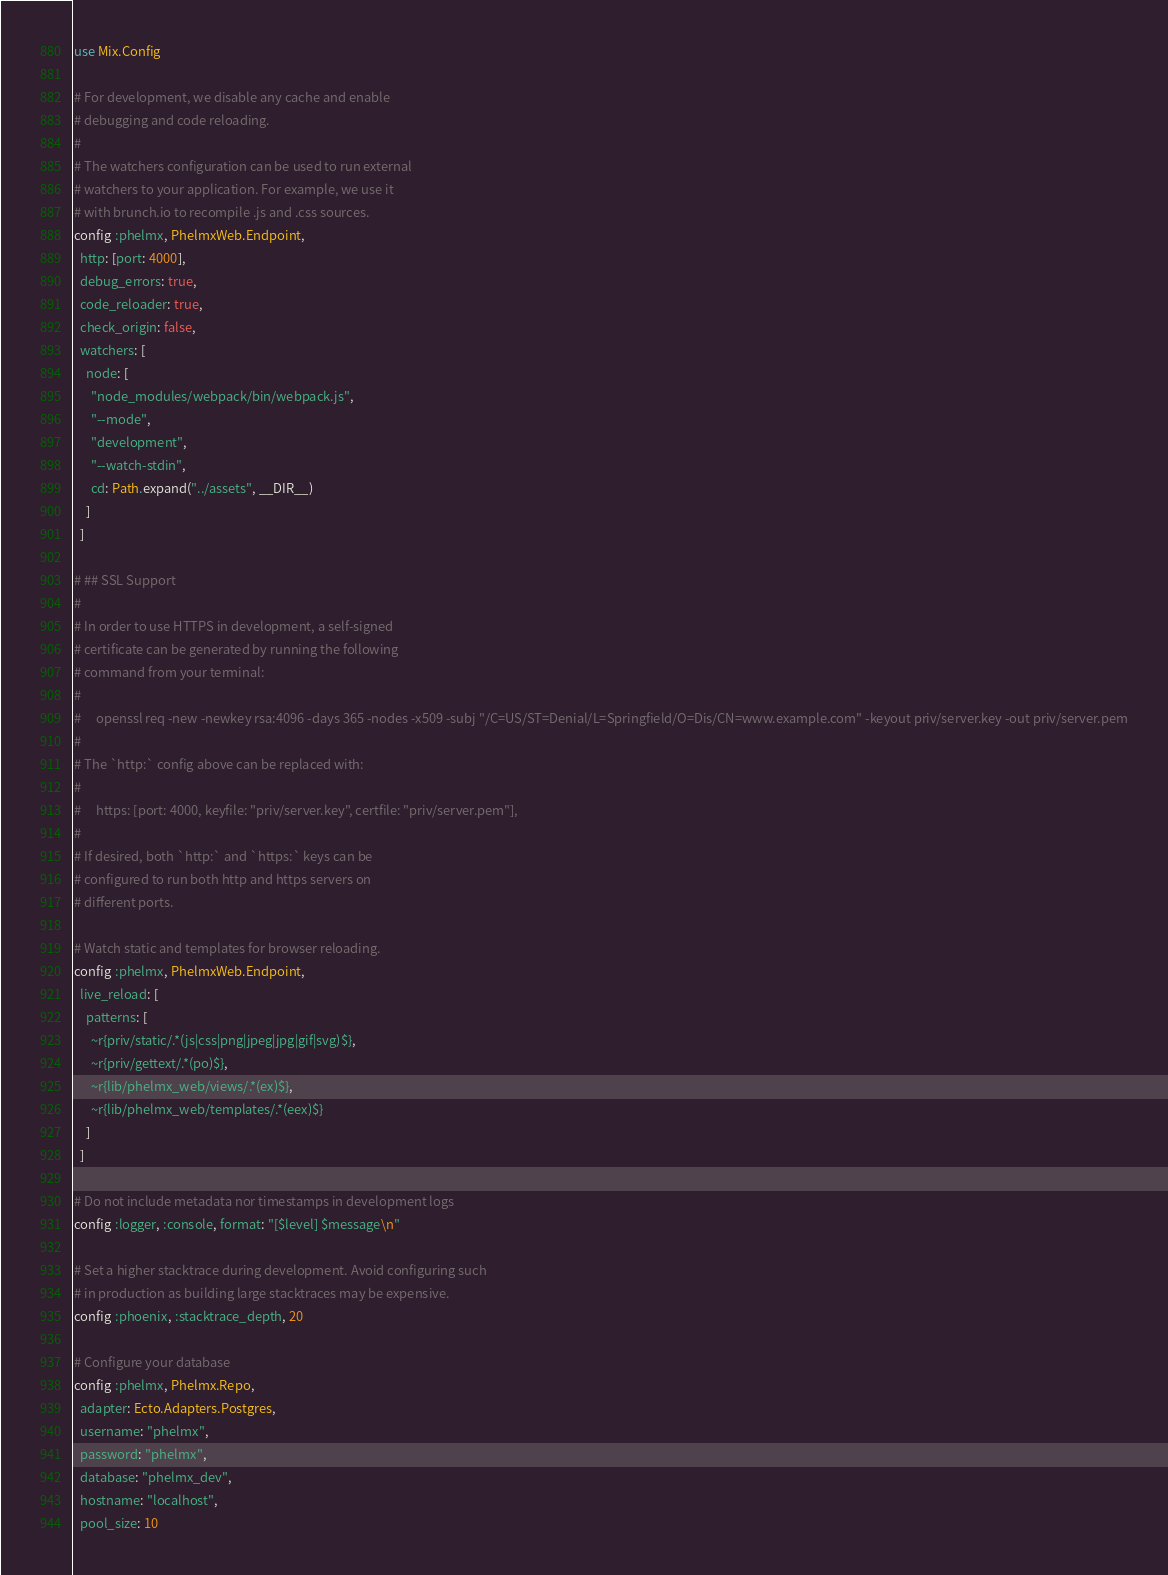Convert code to text. <code><loc_0><loc_0><loc_500><loc_500><_Elixir_>use Mix.Config

# For development, we disable any cache and enable
# debugging and code reloading.
#
# The watchers configuration can be used to run external
# watchers to your application. For example, we use it
# with brunch.io to recompile .js and .css sources.
config :phelmx, PhelmxWeb.Endpoint,
  http: [port: 4000],
  debug_errors: true,
  code_reloader: true,
  check_origin: false,
  watchers: [
    node: [
      "node_modules/webpack/bin/webpack.js",
      "--mode",
      "development",
      "--watch-stdin",
      cd: Path.expand("../assets", __DIR__)
    ]
  ]

# ## SSL Support
#
# In order to use HTTPS in development, a self-signed
# certificate can be generated by running the following
# command from your terminal:
#
#     openssl req -new -newkey rsa:4096 -days 365 -nodes -x509 -subj "/C=US/ST=Denial/L=Springfield/O=Dis/CN=www.example.com" -keyout priv/server.key -out priv/server.pem
#
# The `http:` config above can be replaced with:
#
#     https: [port: 4000, keyfile: "priv/server.key", certfile: "priv/server.pem"],
#
# If desired, both `http:` and `https:` keys can be
# configured to run both http and https servers on
# different ports.

# Watch static and templates for browser reloading.
config :phelmx, PhelmxWeb.Endpoint,
  live_reload: [
    patterns: [
      ~r{priv/static/.*(js|css|png|jpeg|jpg|gif|svg)$},
      ~r{priv/gettext/.*(po)$},
      ~r{lib/phelmx_web/views/.*(ex)$},
      ~r{lib/phelmx_web/templates/.*(eex)$}
    ]
  ]

# Do not include metadata nor timestamps in development logs
config :logger, :console, format: "[$level] $message\n"

# Set a higher stacktrace during development. Avoid configuring such
# in production as building large stacktraces may be expensive.
config :phoenix, :stacktrace_depth, 20

# Configure your database
config :phelmx, Phelmx.Repo,
  adapter: Ecto.Adapters.Postgres,
  username: "phelmx",
  password: "phelmx",
  database: "phelmx_dev",
  hostname: "localhost",
  pool_size: 10
</code> 